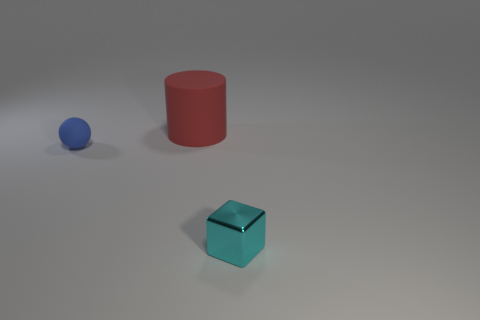Add 3 metal cubes. How many objects exist? 6 Subtract all blocks. How many objects are left? 2 Subtract 0 blue cubes. How many objects are left? 3 Subtract 1 blocks. How many blocks are left? 0 Subtract all purple blocks. Subtract all blue spheres. How many blocks are left? 1 Subtract all small blue blocks. Subtract all cylinders. How many objects are left? 2 Add 2 tiny blue rubber spheres. How many tiny blue rubber spheres are left? 3 Add 2 big shiny objects. How many big shiny objects exist? 2 